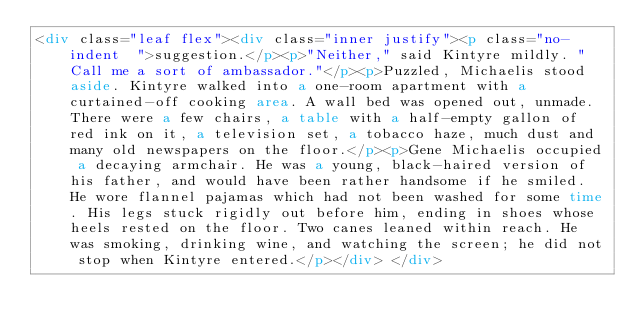<code> <loc_0><loc_0><loc_500><loc_500><_HTML_><div class="leaf flex"><div class="inner justify"><p class="no-indent  ">suggestion.</p><p>"Neither," said Kintyre mildly. "Call me a sort of ambassador."</p><p>Puzzled, Michaelis stood aside. Kintyre walked into a one-room apartment with a curtained-off cooking area. A wall bed was opened out, unmade. There were a few chairs, a table with a half-empty gallon of red ink on it, a television set, a tobacco haze, much dust and many old newspapers on the floor.</p><p>Gene Michaelis occupied a decaying armchair. He was a young, black-haired version of his father, and would have been rather handsome if he smiled. He wore flannel pajamas which had not been washed for some time. His legs stuck rigidly out before him, ending in shoes whose heels rested on the floor. Two canes leaned within reach. He was smoking, drinking wine, and watching the screen; he did not stop when Kintyre entered.</p></div> </div></code> 